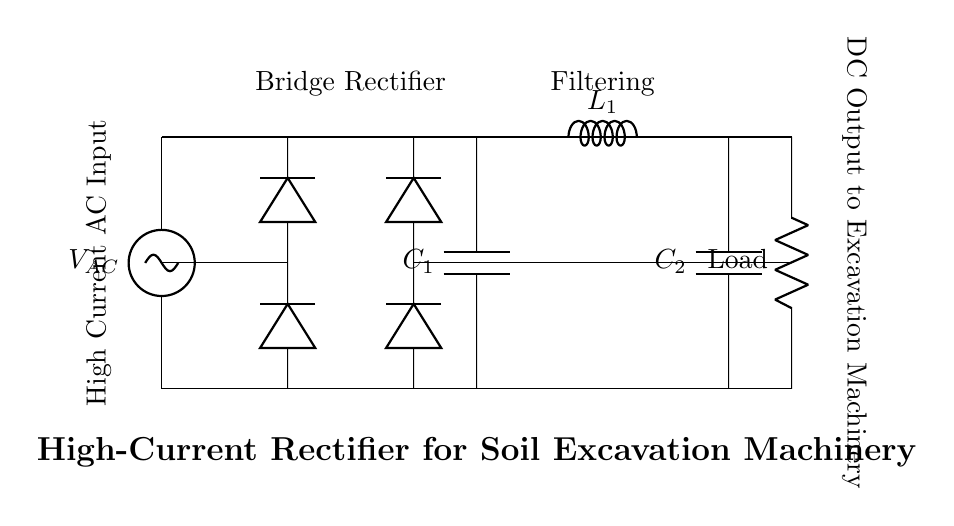What is the type of rectifier shown in the circuit? The circuit diagram displays a bridge rectifier, which is characterized by four diodes arranged in a bridge configuration to convert AC to DC.
Answer: Bridge rectifier What is the function of capacitor C1 in this circuit? Capacitor C1 acts as a smoothing capacitor that helps to reduce voltage fluctuations in the output from the rectifier, providing a more stable DC voltage.
Answer: Smoothing What component is used to filter the output? The inductor L1 is employed in conjunction with capacitor C2 to filter the output, smoothing out the DC voltage further and reducing ripple.
Answer: Inductor What are the input and output types of this circuit? The input is Alternating Current (AC) from the power source, and the output is Direct Current (DC) supplied to the load (excavation machinery).
Answer: AC input and DC output How many diodes are used in the bridge rectifier section? The bridge rectifier consists of four diodes, which work together to allow current to flow in one direction, effectively converting the AC input to a pulsating DC output.
Answer: Four What is the purpose of the load in this circuit? The load represents the heavy-duty soil excavation machinery that consumes the rectified DC power supplied by the circuit for its operation.
Answer: Excavation machinery What does the smoothing capacitor C2 do in this setup? Capacitor C2 serves to further filter the DC output by smoothing the remaining voltage ripple after rectification and filtering, improving the overall quality of the power supplied to the load.
Answer: Further filtering 